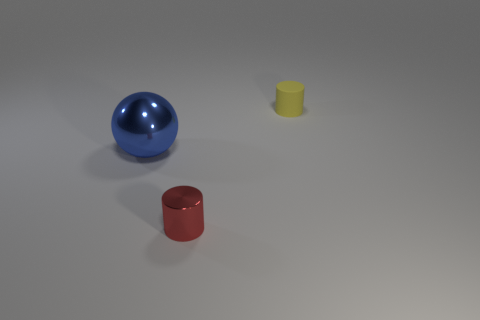Add 1 shiny cylinders. How many objects exist? 4 Subtract all cylinders. How many objects are left? 1 Add 3 big blue things. How many big blue things are left? 4 Add 3 tiny green shiny cylinders. How many tiny green shiny cylinders exist? 3 Subtract 0 yellow balls. How many objects are left? 3 Subtract all tiny yellow things. Subtract all tiny red metal cylinders. How many objects are left? 1 